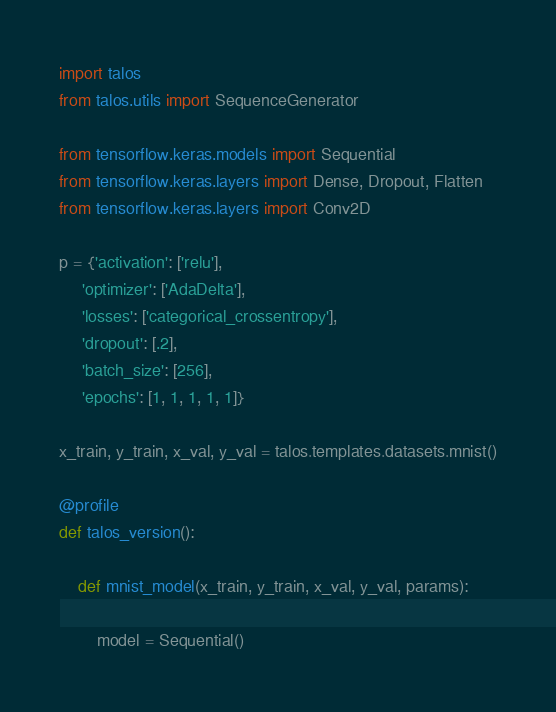Convert code to text. <code><loc_0><loc_0><loc_500><loc_500><_Python_>import talos
from talos.utils import SequenceGenerator

from tensorflow.keras.models import Sequential
from tensorflow.keras.layers import Dense, Dropout, Flatten
from tensorflow.keras.layers import Conv2D

p = {'activation': ['relu'],
     'optimizer': ['AdaDelta'],
     'losses': ['categorical_crossentropy'],
     'dropout': [.2],
     'batch_size': [256],
     'epochs': [1, 1, 1, 1, 1]}

x_train, y_train, x_val, y_val = talos.templates.datasets.mnist()

@profile
def talos_version():

    def mnist_model(x_train, y_train, x_val, y_val, params):

        model = Sequential()</code> 